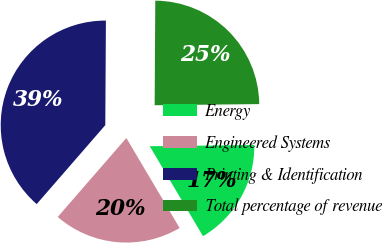Convert chart. <chart><loc_0><loc_0><loc_500><loc_500><pie_chart><fcel>Energy<fcel>Engineered Systems<fcel>Printing & Identification<fcel>Total percentage of revenue<nl><fcel>16.67%<fcel>19.89%<fcel>38.71%<fcel>24.73%<nl></chart> 